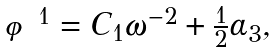<formula> <loc_0><loc_0><loc_500><loc_500>\begin{array} { l } \varphi ^ { 1 } = C _ { 1 } \omega ^ { - 2 } + \frac { 1 } { 2 } \alpha _ { 3 } , \end{array}</formula> 